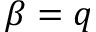<formula> <loc_0><loc_0><loc_500><loc_500>\beta = q</formula> 